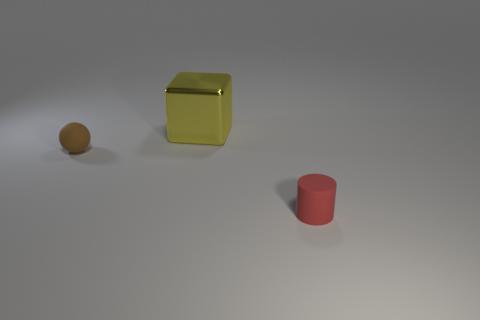Are there any other things that have the same size as the red cylinder?
Your answer should be compact. Yes. How many big objects are green metallic balls or red things?
Provide a short and direct response. 0. Is the number of brown spheres less than the number of large yellow rubber cylinders?
Make the answer very short. No. Is there anything else that has the same shape as the small red matte thing?
Provide a succinct answer. No. Are there more big yellow cubes than brown matte cylinders?
Your answer should be very brief. Yes. How many other objects are the same material as the ball?
Offer a terse response. 1. The small thing that is right of the small rubber object that is to the left of the small matte thing in front of the tiny brown thing is what shape?
Your response must be concise. Cylinder. Are there fewer yellow cubes to the left of the large yellow block than objects that are behind the cylinder?
Provide a succinct answer. Yes. Is the material of the red cylinder the same as the tiny object to the left of the cylinder?
Ensure brevity in your answer.  Yes. There is a rubber object right of the brown rubber thing; are there any big metallic cubes left of it?
Your answer should be compact. Yes. 